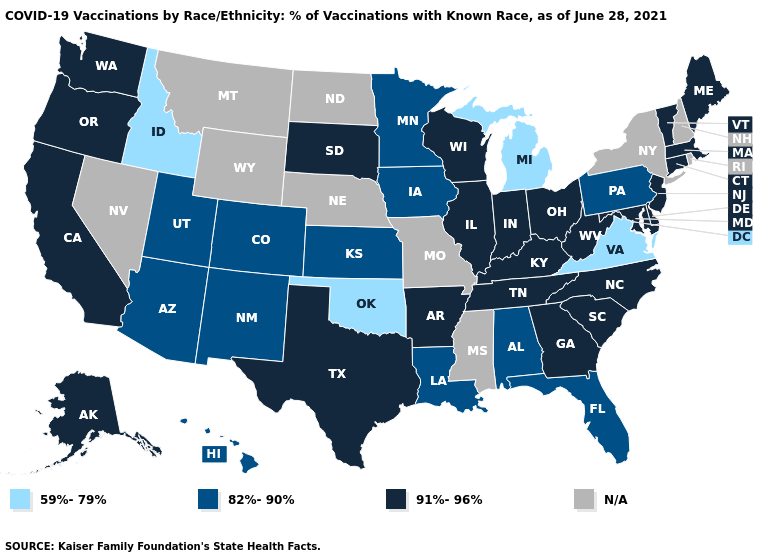Does Idaho have the lowest value in the West?
Be succinct. Yes. Which states have the lowest value in the USA?
Give a very brief answer. Idaho, Michigan, Oklahoma, Virginia. Is the legend a continuous bar?
Quick response, please. No. Which states hav the highest value in the Northeast?
Keep it brief. Connecticut, Maine, Massachusetts, New Jersey, Vermont. What is the highest value in the MidWest ?
Answer briefly. 91%-96%. What is the value of Georgia?
Write a very short answer. 91%-96%. Name the states that have a value in the range 59%-79%?
Keep it brief. Idaho, Michigan, Oklahoma, Virginia. Name the states that have a value in the range 59%-79%?
Write a very short answer. Idaho, Michigan, Oklahoma, Virginia. What is the value of North Dakota?
Keep it brief. N/A. Name the states that have a value in the range 82%-90%?
Short answer required. Alabama, Arizona, Colorado, Florida, Hawaii, Iowa, Kansas, Louisiana, Minnesota, New Mexico, Pennsylvania, Utah. Among the states that border Indiana , does Kentucky have the highest value?
Short answer required. Yes. What is the value of Arkansas?
Quick response, please. 91%-96%. What is the highest value in the West ?
Short answer required. 91%-96%. Name the states that have a value in the range 82%-90%?
Concise answer only. Alabama, Arizona, Colorado, Florida, Hawaii, Iowa, Kansas, Louisiana, Minnesota, New Mexico, Pennsylvania, Utah. 